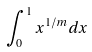<formula> <loc_0><loc_0><loc_500><loc_500>\int _ { 0 } ^ { 1 } x ^ { 1 / m } d x</formula> 